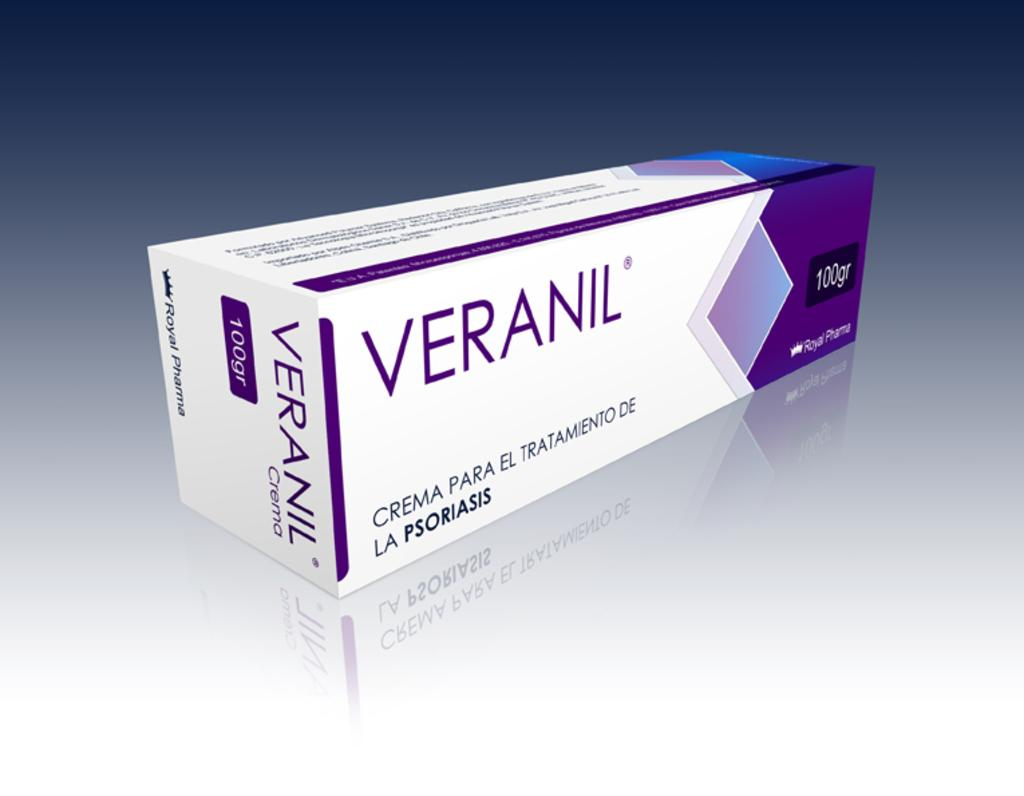<image>
Summarize the visual content of the image. A box of Veranil from Royal Pharma has 100 grams. 